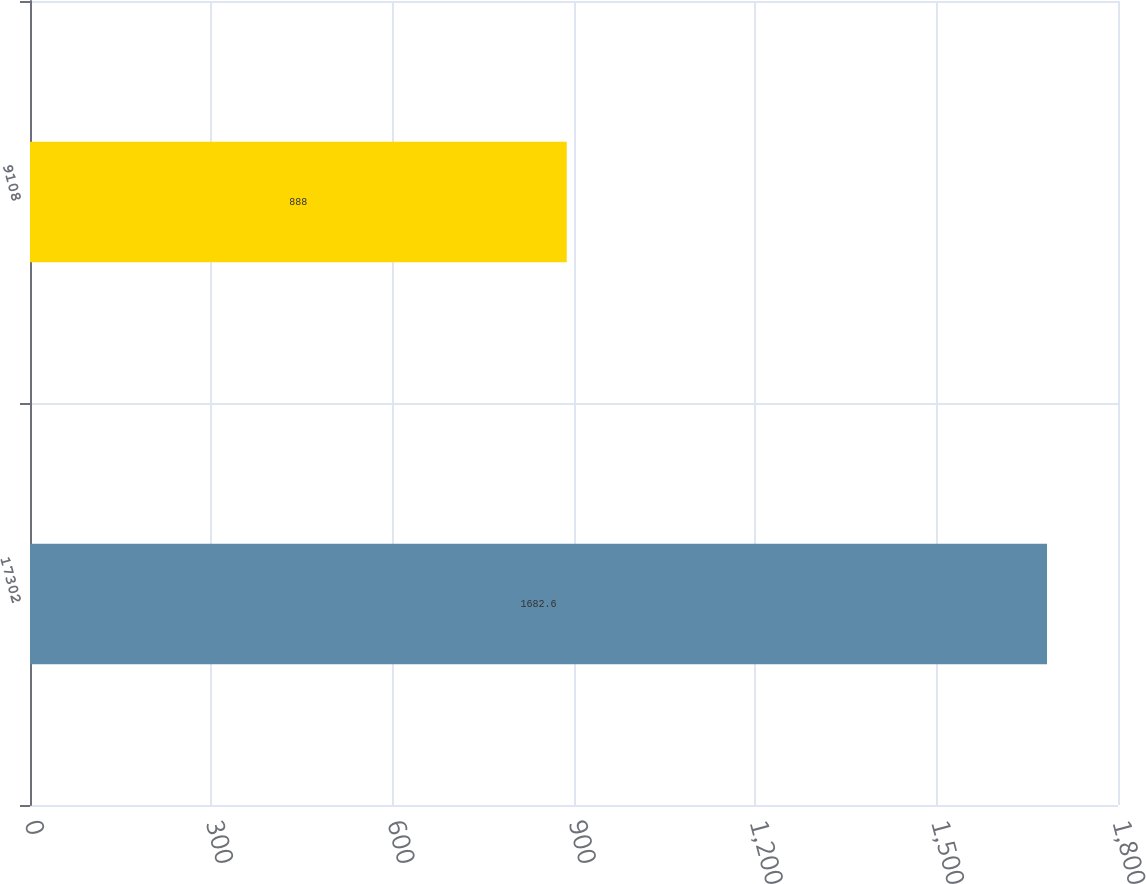<chart> <loc_0><loc_0><loc_500><loc_500><bar_chart><fcel>17302<fcel>9108<nl><fcel>1682.6<fcel>888<nl></chart> 